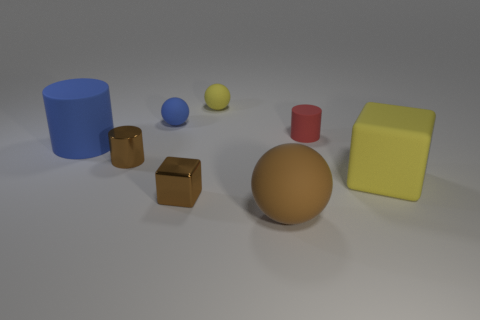Subtract all blue cylinders. How many cylinders are left? 2 Subtract all brown cylinders. How many cylinders are left? 2 Subtract 2 blocks. How many blocks are left? 0 Add 1 brown matte things. How many objects exist? 9 Subtract all cubes. How many objects are left? 6 Subtract all red cylinders. Subtract all yellow spheres. How many cylinders are left? 2 Subtract all blue metal spheres. Subtract all tiny blue things. How many objects are left? 7 Add 3 large yellow matte blocks. How many large yellow matte blocks are left? 4 Add 6 large metal cylinders. How many large metal cylinders exist? 6 Subtract 1 brown balls. How many objects are left? 7 